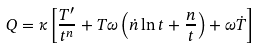Convert formula to latex. <formula><loc_0><loc_0><loc_500><loc_500>Q = \kappa \left [ \frac { T ^ { \prime } } { t ^ { n } } + T \omega \left ( \dot { n } \ln { t } + \frac { n } { t } \right ) + \omega \dot { T } \right ]</formula> 